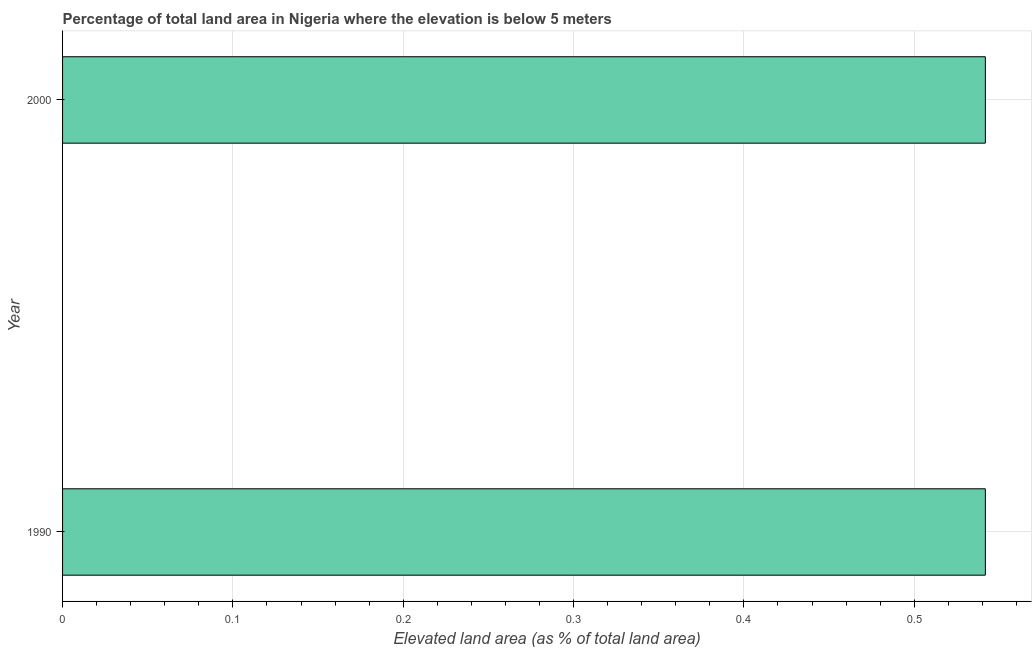What is the title of the graph?
Offer a very short reply. Percentage of total land area in Nigeria where the elevation is below 5 meters. What is the label or title of the X-axis?
Your answer should be very brief. Elevated land area (as % of total land area). What is the label or title of the Y-axis?
Your answer should be compact. Year. What is the total elevated land area in 1990?
Provide a short and direct response. 0.54. Across all years, what is the maximum total elevated land area?
Make the answer very short. 0.54. Across all years, what is the minimum total elevated land area?
Offer a very short reply. 0.54. In which year was the total elevated land area maximum?
Give a very brief answer. 1990. What is the sum of the total elevated land area?
Keep it short and to the point. 1.08. What is the difference between the total elevated land area in 1990 and 2000?
Give a very brief answer. 0. What is the average total elevated land area per year?
Your answer should be compact. 0.54. What is the median total elevated land area?
Make the answer very short. 0.54. What is the ratio of the total elevated land area in 1990 to that in 2000?
Give a very brief answer. 1. In how many years, is the total elevated land area greater than the average total elevated land area taken over all years?
Ensure brevity in your answer.  0. How many bars are there?
Offer a very short reply. 2. Are all the bars in the graph horizontal?
Keep it short and to the point. Yes. Are the values on the major ticks of X-axis written in scientific E-notation?
Your answer should be very brief. No. What is the Elevated land area (as % of total land area) of 1990?
Give a very brief answer. 0.54. What is the Elevated land area (as % of total land area) of 2000?
Your response must be concise. 0.54. What is the difference between the Elevated land area (as % of total land area) in 1990 and 2000?
Offer a very short reply. 0. 